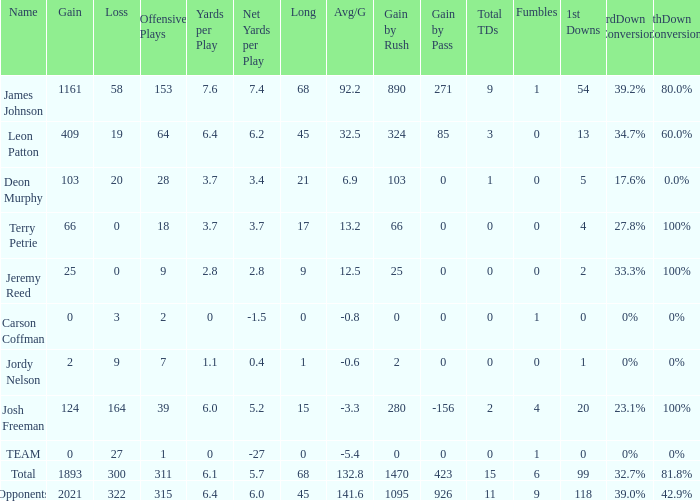How many losses did leon patton have with the longest gain higher than 45? 0.0. 